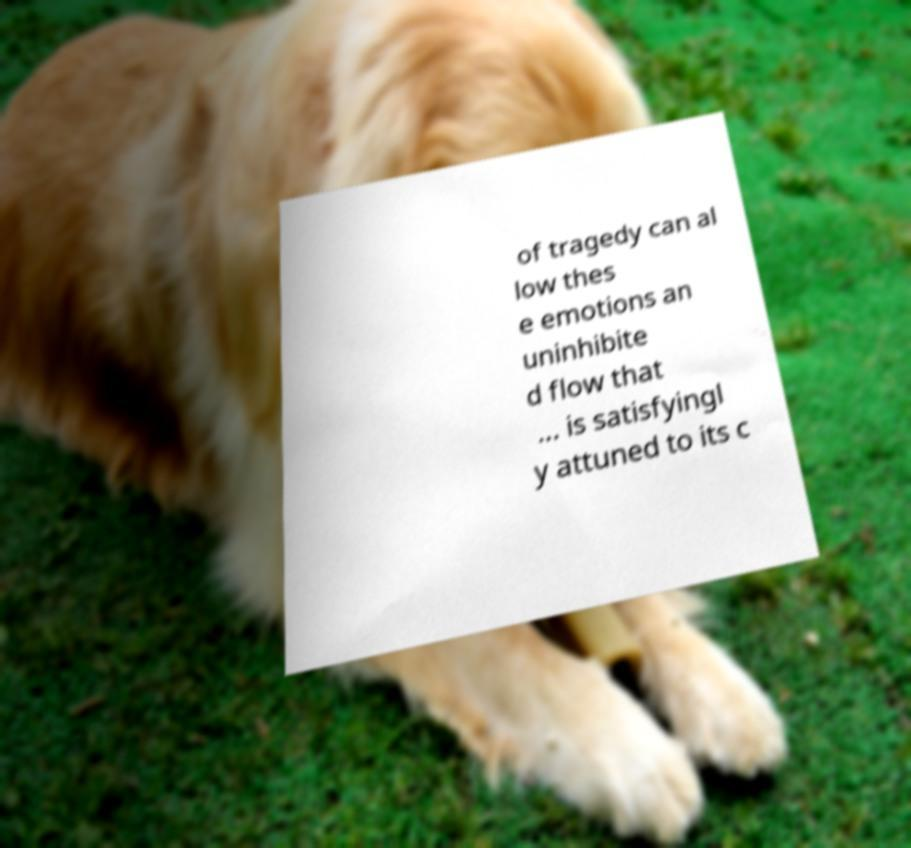Can you accurately transcribe the text from the provided image for me? of tragedy can al low thes e emotions an uninhibite d flow that ... is satisfyingl y attuned to its c 